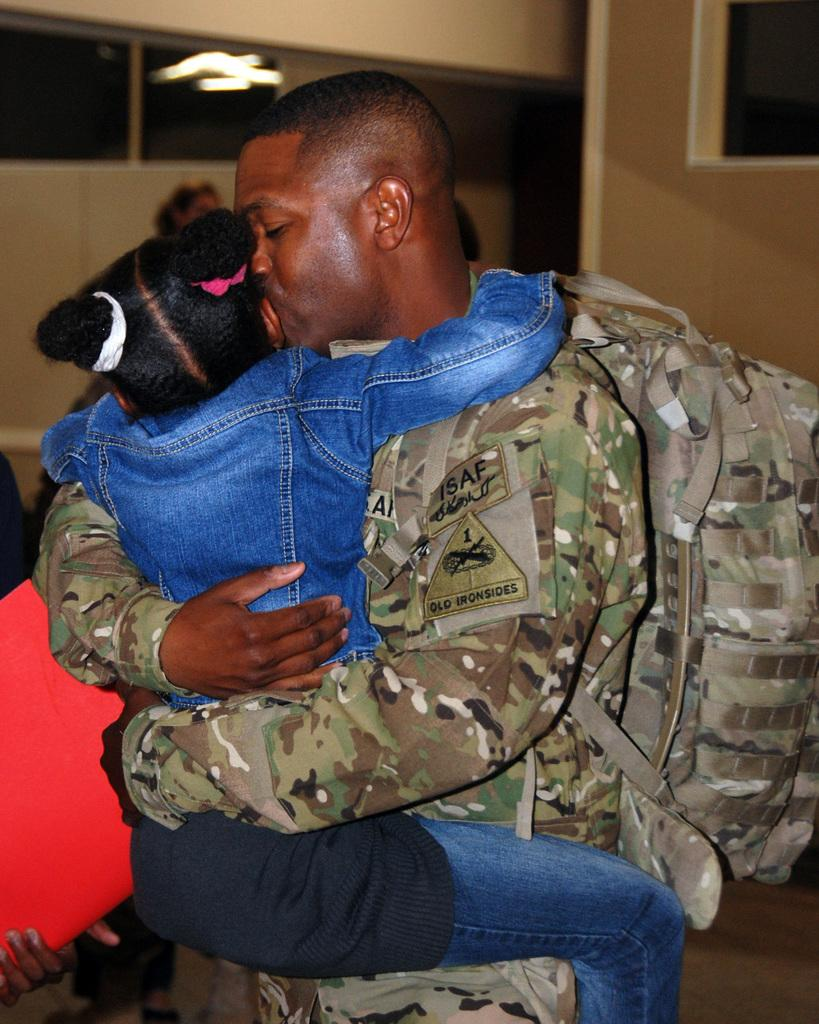How many people are in the image? There are two people in the image. What are the two people doing in the image? The two people are hugging each other. What is visible at the bottom of the image? There is a floor visible at the bottom of the image. What can be seen in the background of the image? There is a wall in the background of the image. What type of seed can be seen growing on the wall in the image? There is no seed growing on the wall in the image; it only shows two people hugging each other with a floor and a wall visible. 